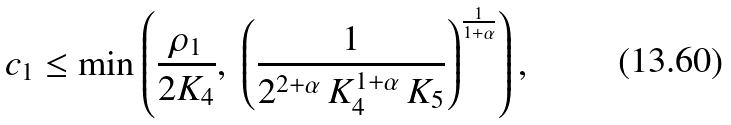Convert formula to latex. <formula><loc_0><loc_0><loc_500><loc_500>c _ { 1 } \leq \min \left ( \frac { \rho _ { 1 } } { 2 K _ { 4 } } , \ \left ( \frac { 1 } { 2 ^ { 2 + \alpha } \, K _ { 4 } ^ { 1 + \alpha } \, K _ { 5 } } \right ) ^ { \frac { 1 } { 1 + \alpha } } \right ) ,</formula> 